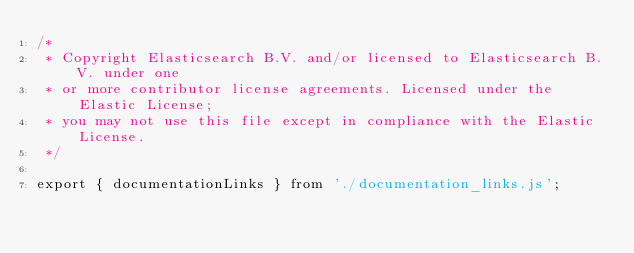Convert code to text. <code><loc_0><loc_0><loc_500><loc_500><_JavaScript_>/*
 * Copyright Elasticsearch B.V. and/or licensed to Elasticsearch B.V. under one
 * or more contributor license agreements. Licensed under the Elastic License;
 * you may not use this file except in compliance with the Elastic License.
 */

export { documentationLinks } from './documentation_links.js';
</code> 